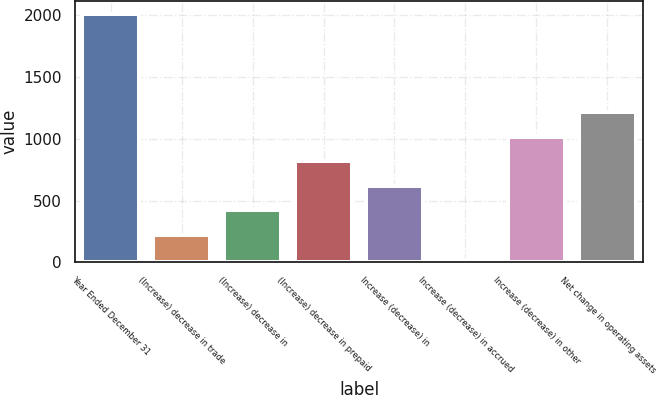Convert chart. <chart><loc_0><loc_0><loc_500><loc_500><bar_chart><fcel>Year Ended December 31<fcel>(Increase) decrease in trade<fcel>(Increase) decrease in<fcel>(Increase) decrease in prepaid<fcel>Increase (decrease) in<fcel>Increase (decrease) in accrued<fcel>Increase (decrease) in other<fcel>Net change in operating assets<nl><fcel>2013<fcel>221.1<fcel>420.2<fcel>818.4<fcel>619.3<fcel>22<fcel>1017.5<fcel>1216.6<nl></chart> 